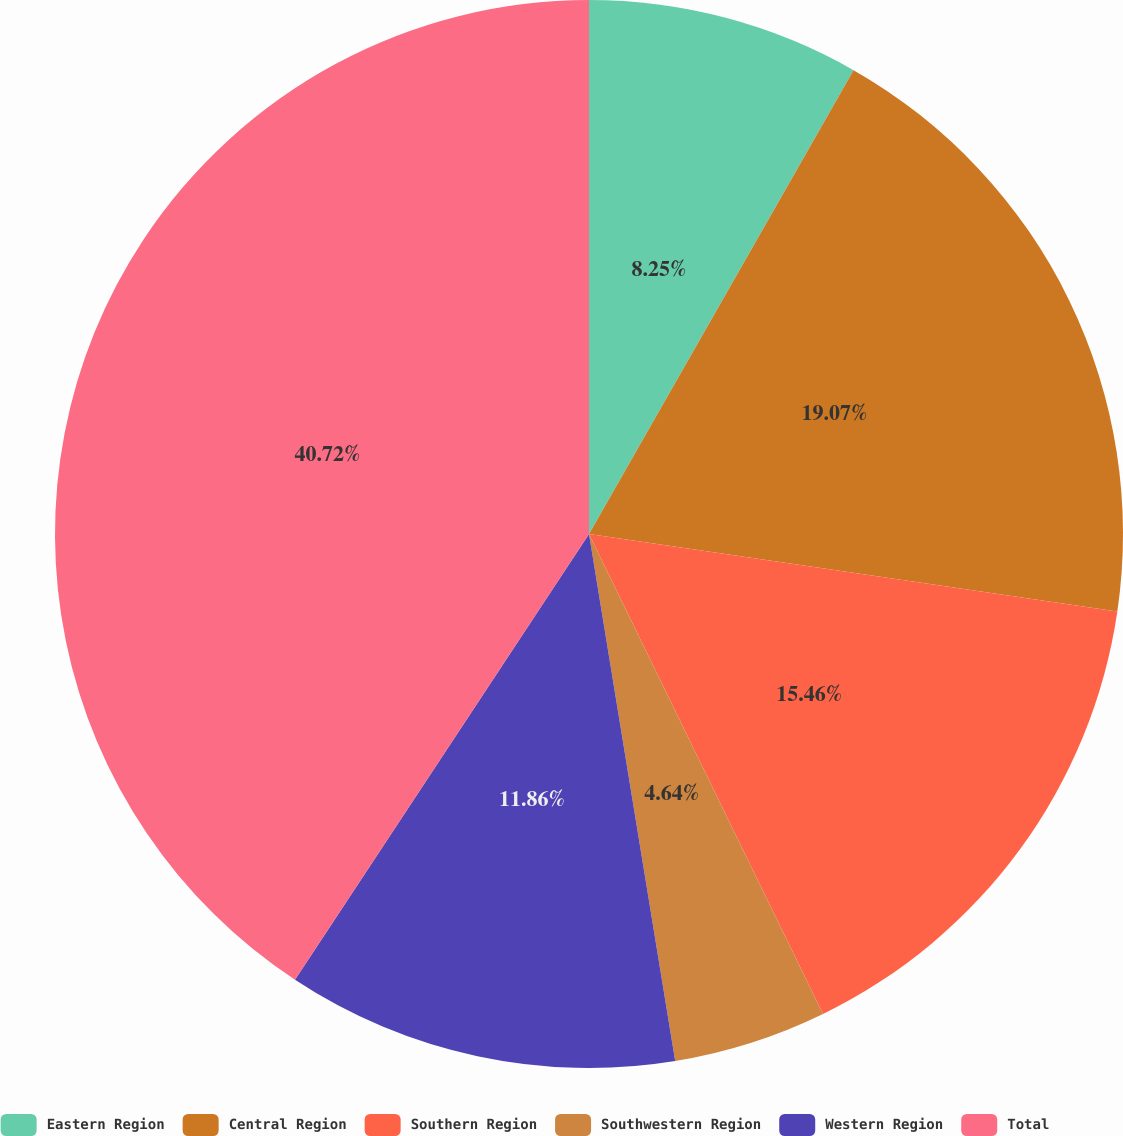Convert chart to OTSL. <chart><loc_0><loc_0><loc_500><loc_500><pie_chart><fcel>Eastern Region<fcel>Central Region<fcel>Southern Region<fcel>Southwestern Region<fcel>Western Region<fcel>Total<nl><fcel>8.25%<fcel>19.07%<fcel>15.46%<fcel>4.64%<fcel>11.86%<fcel>40.72%<nl></chart> 